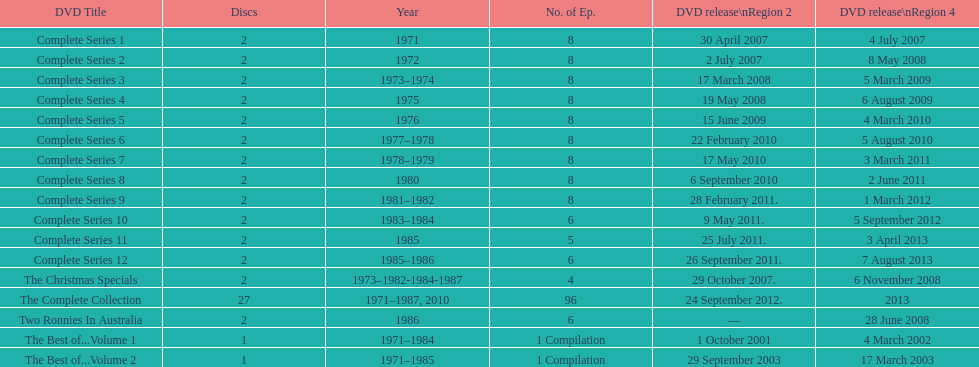What is the sum of all discs listed in the table? 57. 